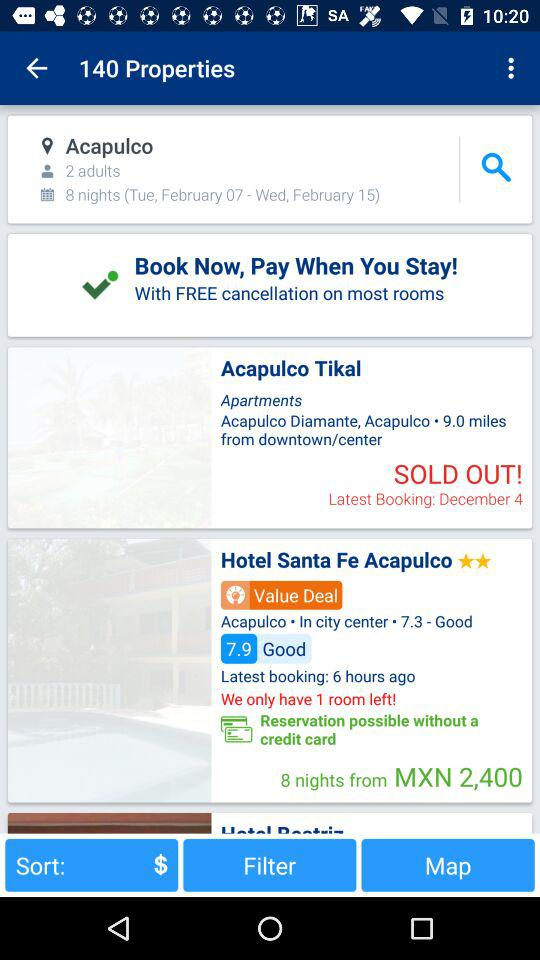How much does a room at the Hotel Santa Fe Acapulco cost?
When the provided information is insufficient, respond with <no answer>. <no answer> 